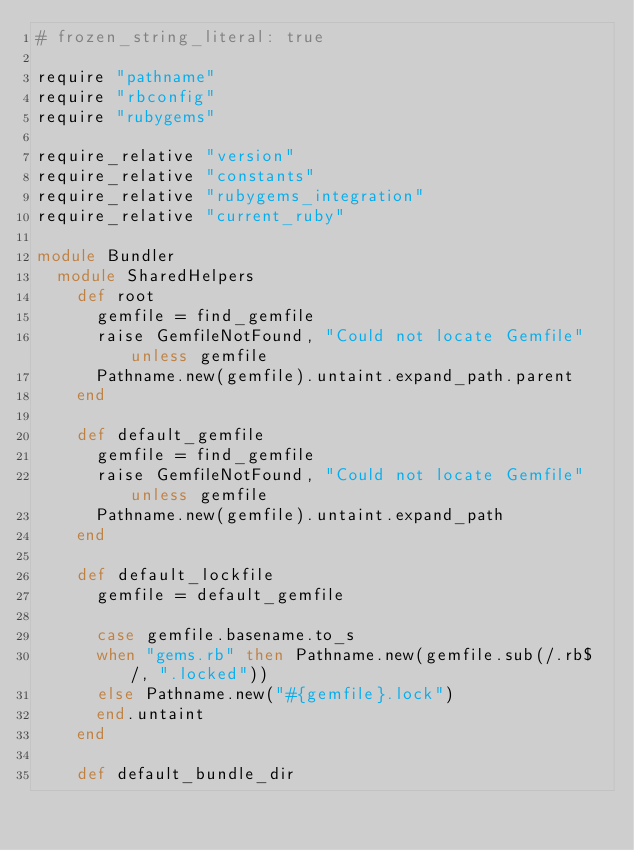<code> <loc_0><loc_0><loc_500><loc_500><_Ruby_># frozen_string_literal: true

require "pathname"
require "rbconfig"
require "rubygems"

require_relative "version"
require_relative "constants"
require_relative "rubygems_integration"
require_relative "current_ruby"

module Bundler
  module SharedHelpers
    def root
      gemfile = find_gemfile
      raise GemfileNotFound, "Could not locate Gemfile" unless gemfile
      Pathname.new(gemfile).untaint.expand_path.parent
    end

    def default_gemfile
      gemfile = find_gemfile
      raise GemfileNotFound, "Could not locate Gemfile" unless gemfile
      Pathname.new(gemfile).untaint.expand_path
    end

    def default_lockfile
      gemfile = default_gemfile

      case gemfile.basename.to_s
      when "gems.rb" then Pathname.new(gemfile.sub(/.rb$/, ".locked"))
      else Pathname.new("#{gemfile}.lock")
      end.untaint
    end

    def default_bundle_dir</code> 